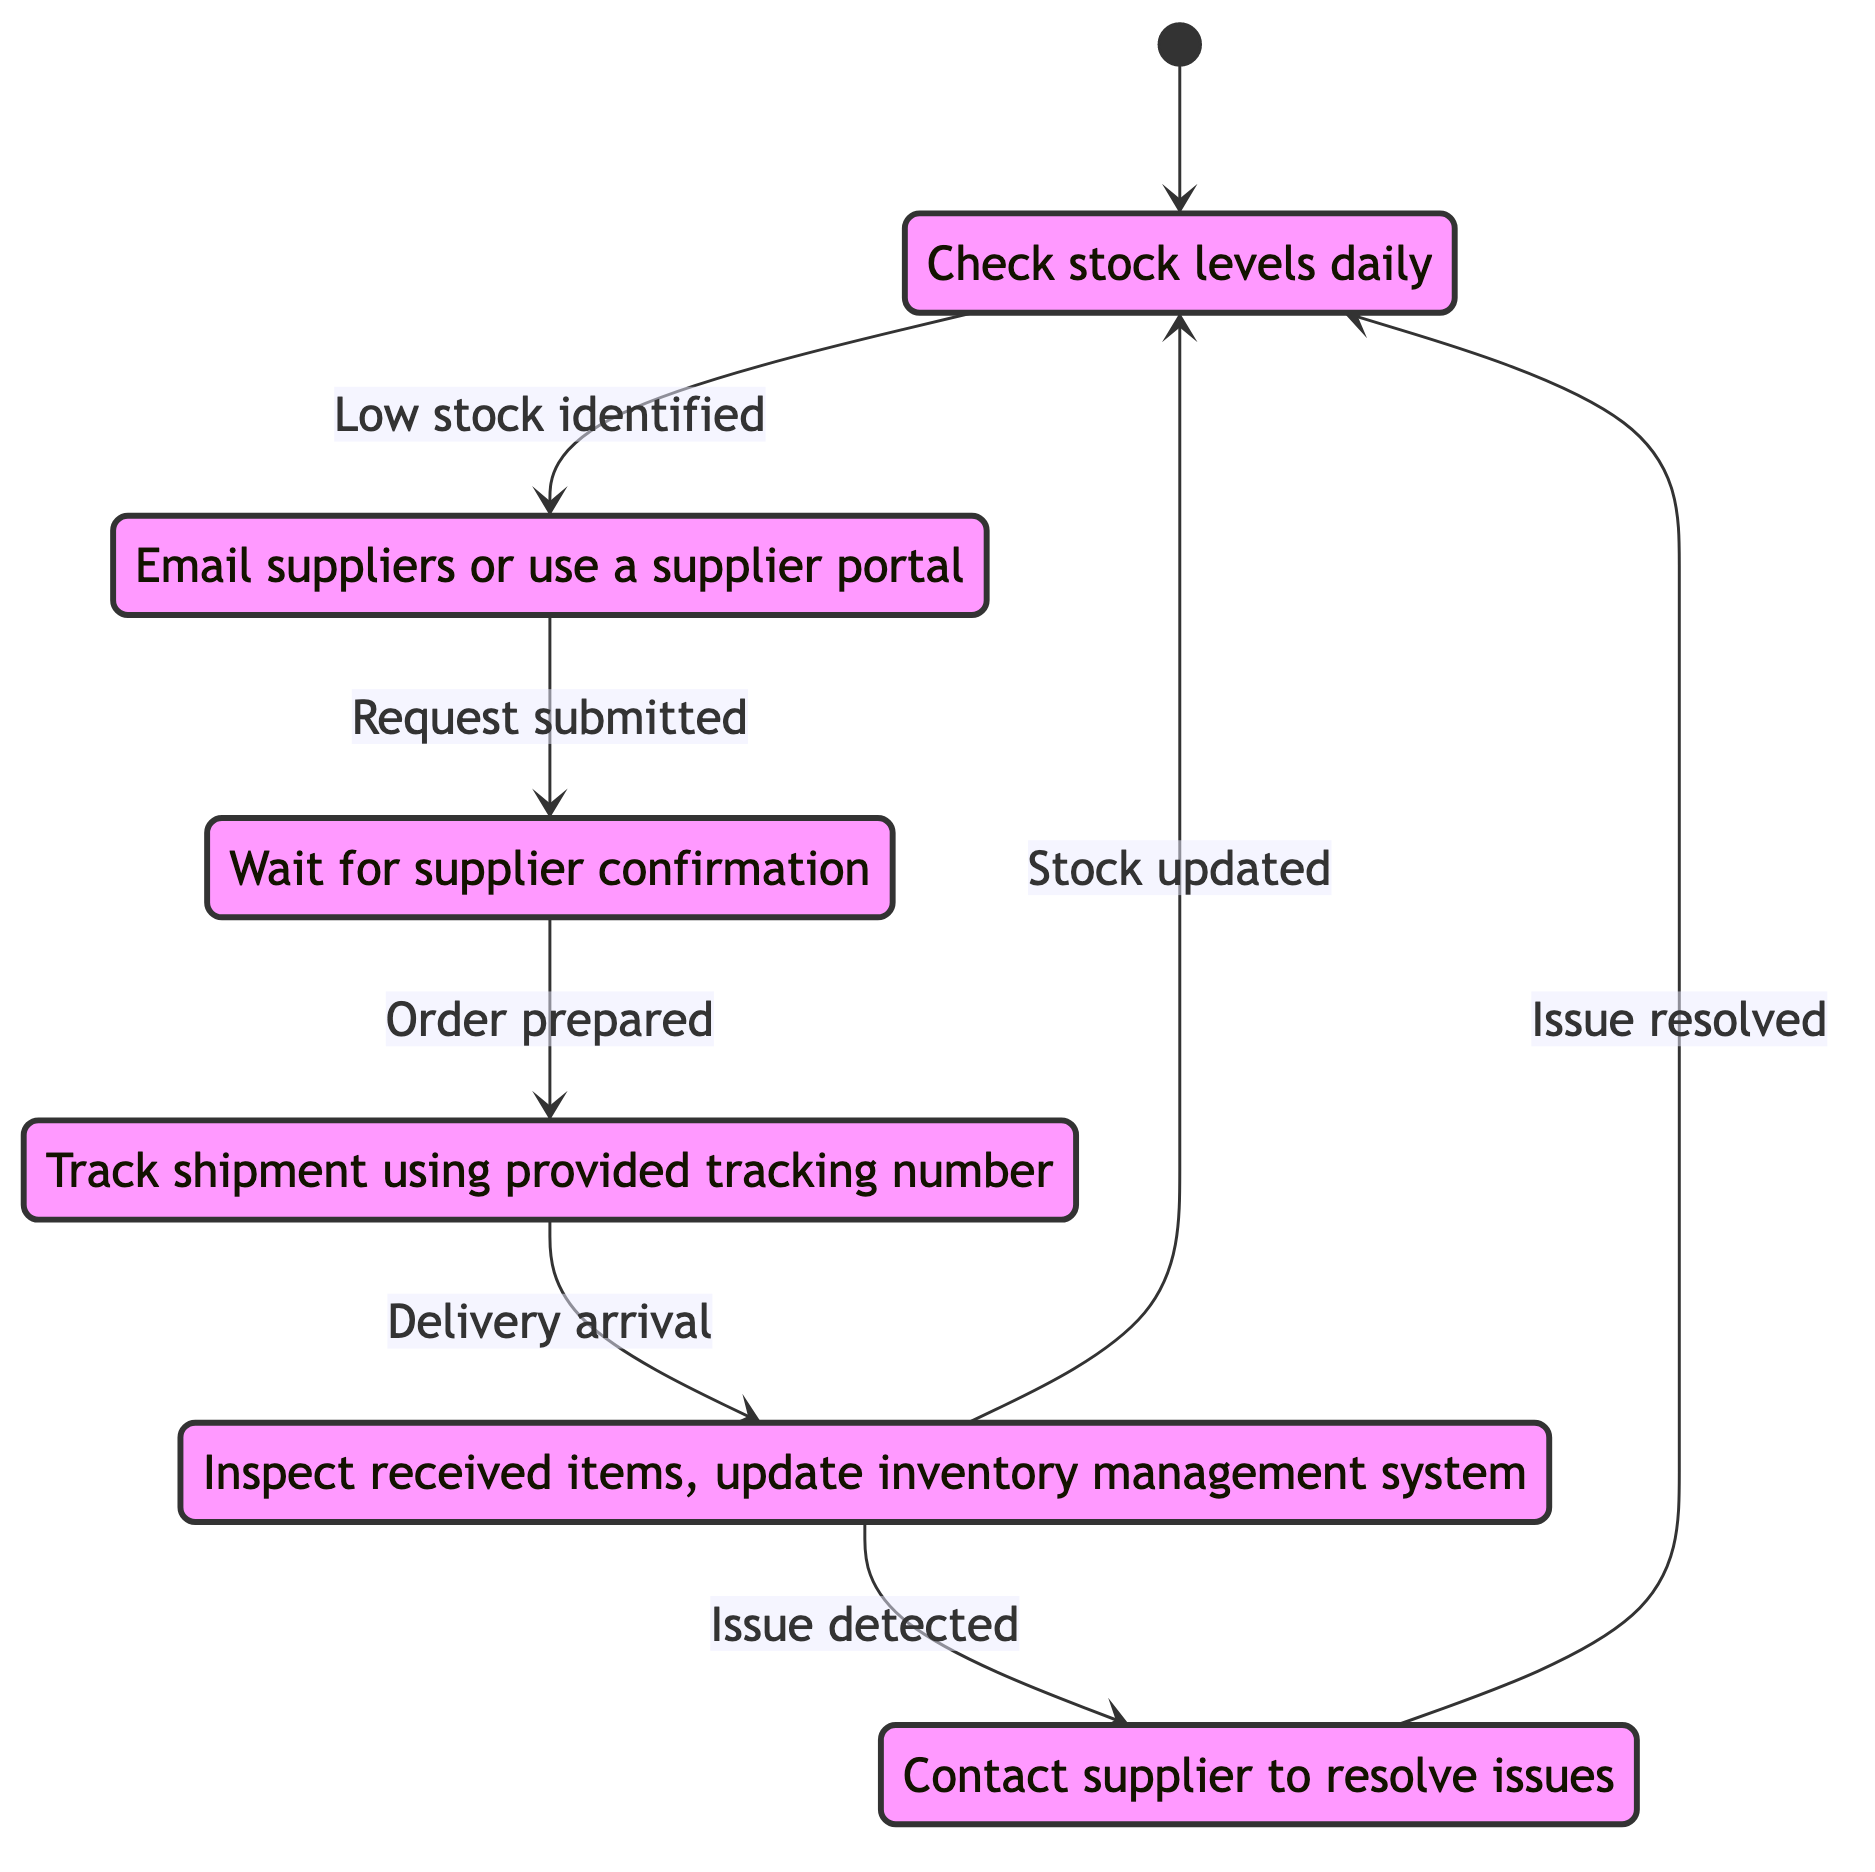What is the initial state of the diagram? The initial state is represented by the entry point [*], which transitions to the state "Inventory Review".
Answer: Inventory Review How many states are present in the diagram? By counting the listed states in the diagram, we find there are a total of six states: Inventory Review, Restock Request Submission, Supplier Processing, In-Transit, Delivery Received, and Issue Resolution.
Answer: 6 What triggers the transition from "In-Transit" to "Delivery Received"? The transition from "In-Transit" to "Delivery Received" occurs when the event "Delivery arrival" happens, indicating that the goods are arriving at the store.
Answer: Delivery arrival What action is associated with the state "Delivery Received"? The action linked to the state "Delivery Received" involves inspecting received items and updating the inventory management system to ensure the stock levels are correct.
Answer: Inspect received items, update inventory management system What is the relationship between "Delivery Received" and "Issue Resolution"? There are two possible transitions from "Delivery Received": one leads back to "Inventory Review" upon "Stock updated" and another leads to "Issue Resolution" when "Issue detected". This shows that receiving an order might either succeed or have complications that need addressing.
Answer: Two transitions exist: Stock updated -> Inventory Review; Issue detected -> Issue Resolution What is the final state after resolving an issue? After the "Issue Resolution" state successfully handles an issue, the flow returns to "Inventory Review", resuming the cycle of monitoring stock levels.
Answer: Inventory Review What do you do while the order is in the "Supplier Processing" state? When the order is in the "Supplier Processing" state, the action taken is to wait for supplier confirmation, indicating that the store owner cannot do much until the supplier finishes processing the request.
Answer: Wait for supplier confirmation How many transitions are there in total? Counting all the transition pathways described in the diagram, we find there are a total of six transitions connecting the states in various ways.
Answer: 6 What happens if an issue is detected during the delivery? If an issue is detected during delivery, control transitions to the "Issue Resolution" state, where the store needs to deal with the problem before stock can be updated.
Answer: Issue Resolution 